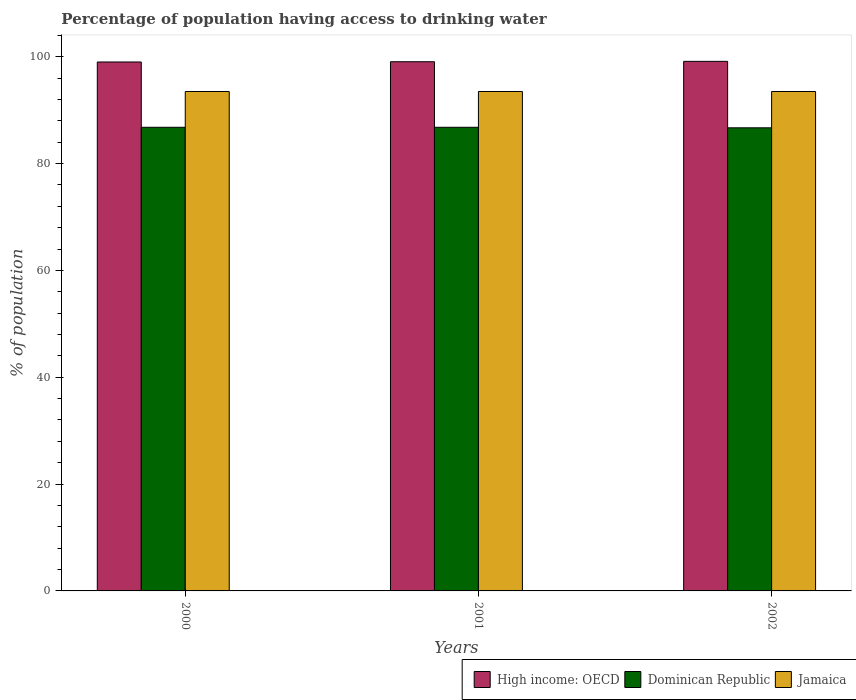How many different coloured bars are there?
Offer a terse response. 3. Are the number of bars on each tick of the X-axis equal?
Your response must be concise. Yes. In how many cases, is the number of bars for a given year not equal to the number of legend labels?
Your answer should be compact. 0. What is the percentage of population having access to drinking water in Dominican Republic in 2001?
Your response must be concise. 86.8. Across all years, what is the maximum percentage of population having access to drinking water in Jamaica?
Ensure brevity in your answer.  93.5. Across all years, what is the minimum percentage of population having access to drinking water in Jamaica?
Your answer should be compact. 93.5. In which year was the percentage of population having access to drinking water in Jamaica minimum?
Offer a very short reply. 2000. What is the total percentage of population having access to drinking water in High income: OECD in the graph?
Give a very brief answer. 297.24. What is the difference between the percentage of population having access to drinking water in High income: OECD in 2000 and that in 2002?
Your answer should be very brief. -0.12. What is the difference between the percentage of population having access to drinking water in High income: OECD in 2001 and the percentage of population having access to drinking water in Jamaica in 2002?
Your answer should be very brief. 5.57. What is the average percentage of population having access to drinking water in Dominican Republic per year?
Offer a terse response. 86.77. In the year 2000, what is the difference between the percentage of population having access to drinking water in High income: OECD and percentage of population having access to drinking water in Jamaica?
Make the answer very short. 5.52. In how many years, is the percentage of population having access to drinking water in Jamaica greater than 52 %?
Offer a very short reply. 3. Is the percentage of population having access to drinking water in Jamaica in 2001 less than that in 2002?
Offer a terse response. No. Is the sum of the percentage of population having access to drinking water in Dominican Republic in 2000 and 2002 greater than the maximum percentage of population having access to drinking water in High income: OECD across all years?
Your answer should be very brief. Yes. What does the 1st bar from the left in 2000 represents?
Give a very brief answer. High income: OECD. What does the 3rd bar from the right in 2001 represents?
Ensure brevity in your answer.  High income: OECD. What is the difference between two consecutive major ticks on the Y-axis?
Keep it short and to the point. 20. Are the values on the major ticks of Y-axis written in scientific E-notation?
Keep it short and to the point. No. Does the graph contain grids?
Ensure brevity in your answer.  No. Where does the legend appear in the graph?
Make the answer very short. Bottom right. How many legend labels are there?
Make the answer very short. 3. How are the legend labels stacked?
Your answer should be very brief. Horizontal. What is the title of the graph?
Your response must be concise. Percentage of population having access to drinking water. What is the label or title of the Y-axis?
Give a very brief answer. % of population. What is the % of population of High income: OECD in 2000?
Provide a short and direct response. 99.02. What is the % of population in Dominican Republic in 2000?
Offer a terse response. 86.8. What is the % of population of Jamaica in 2000?
Your response must be concise. 93.5. What is the % of population in High income: OECD in 2001?
Your answer should be compact. 99.07. What is the % of population of Dominican Republic in 2001?
Your response must be concise. 86.8. What is the % of population of Jamaica in 2001?
Ensure brevity in your answer.  93.5. What is the % of population of High income: OECD in 2002?
Keep it short and to the point. 99.14. What is the % of population in Dominican Republic in 2002?
Provide a succinct answer. 86.7. What is the % of population of Jamaica in 2002?
Your answer should be very brief. 93.5. Across all years, what is the maximum % of population of High income: OECD?
Give a very brief answer. 99.14. Across all years, what is the maximum % of population of Dominican Republic?
Provide a succinct answer. 86.8. Across all years, what is the maximum % of population of Jamaica?
Provide a succinct answer. 93.5. Across all years, what is the minimum % of population of High income: OECD?
Offer a terse response. 99.02. Across all years, what is the minimum % of population in Dominican Republic?
Provide a short and direct response. 86.7. Across all years, what is the minimum % of population of Jamaica?
Offer a very short reply. 93.5. What is the total % of population in High income: OECD in the graph?
Offer a very short reply. 297.24. What is the total % of population of Dominican Republic in the graph?
Your answer should be compact. 260.3. What is the total % of population in Jamaica in the graph?
Your response must be concise. 280.5. What is the difference between the % of population of High income: OECD in 2000 and that in 2001?
Ensure brevity in your answer.  -0.05. What is the difference between the % of population of High income: OECD in 2000 and that in 2002?
Your answer should be very brief. -0.12. What is the difference between the % of population in Jamaica in 2000 and that in 2002?
Keep it short and to the point. 0. What is the difference between the % of population in High income: OECD in 2001 and that in 2002?
Your answer should be very brief. -0.07. What is the difference between the % of population of Dominican Republic in 2001 and that in 2002?
Your answer should be compact. 0.1. What is the difference between the % of population in High income: OECD in 2000 and the % of population in Dominican Republic in 2001?
Keep it short and to the point. 12.22. What is the difference between the % of population in High income: OECD in 2000 and the % of population in Jamaica in 2001?
Your answer should be compact. 5.52. What is the difference between the % of population in High income: OECD in 2000 and the % of population in Dominican Republic in 2002?
Offer a terse response. 12.32. What is the difference between the % of population of High income: OECD in 2000 and the % of population of Jamaica in 2002?
Keep it short and to the point. 5.52. What is the difference between the % of population of High income: OECD in 2001 and the % of population of Dominican Republic in 2002?
Offer a very short reply. 12.37. What is the difference between the % of population of High income: OECD in 2001 and the % of population of Jamaica in 2002?
Provide a succinct answer. 5.57. What is the average % of population in High income: OECD per year?
Your answer should be very brief. 99.08. What is the average % of population in Dominican Republic per year?
Provide a short and direct response. 86.77. What is the average % of population in Jamaica per year?
Provide a succinct answer. 93.5. In the year 2000, what is the difference between the % of population in High income: OECD and % of population in Dominican Republic?
Make the answer very short. 12.22. In the year 2000, what is the difference between the % of population of High income: OECD and % of population of Jamaica?
Provide a short and direct response. 5.52. In the year 2000, what is the difference between the % of population of Dominican Republic and % of population of Jamaica?
Your response must be concise. -6.7. In the year 2001, what is the difference between the % of population in High income: OECD and % of population in Dominican Republic?
Your answer should be very brief. 12.27. In the year 2001, what is the difference between the % of population in High income: OECD and % of population in Jamaica?
Give a very brief answer. 5.57. In the year 2002, what is the difference between the % of population in High income: OECD and % of population in Dominican Republic?
Your response must be concise. 12.44. In the year 2002, what is the difference between the % of population of High income: OECD and % of population of Jamaica?
Offer a very short reply. 5.64. In the year 2002, what is the difference between the % of population of Dominican Republic and % of population of Jamaica?
Ensure brevity in your answer.  -6.8. What is the ratio of the % of population of Jamaica in 2000 to that in 2001?
Make the answer very short. 1. What is the ratio of the % of population in High income: OECD in 2000 to that in 2002?
Your answer should be very brief. 1. What is the ratio of the % of population of Dominican Republic in 2000 to that in 2002?
Your answer should be very brief. 1. What is the ratio of the % of population of Jamaica in 2000 to that in 2002?
Give a very brief answer. 1. What is the ratio of the % of population of High income: OECD in 2001 to that in 2002?
Offer a very short reply. 1. What is the ratio of the % of population in Jamaica in 2001 to that in 2002?
Ensure brevity in your answer.  1. What is the difference between the highest and the second highest % of population in High income: OECD?
Your answer should be very brief. 0.07. What is the difference between the highest and the second highest % of population in Dominican Republic?
Provide a short and direct response. 0. What is the difference between the highest and the second highest % of population of Jamaica?
Provide a succinct answer. 0. What is the difference between the highest and the lowest % of population in High income: OECD?
Make the answer very short. 0.12. What is the difference between the highest and the lowest % of population of Jamaica?
Give a very brief answer. 0. 